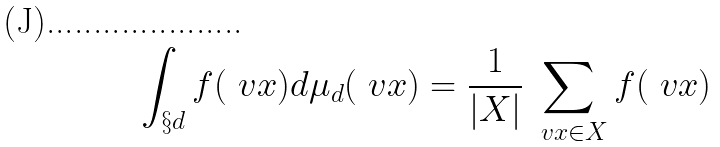<formula> <loc_0><loc_0><loc_500><loc_500>\int _ { \S d } f ( \ v x ) d \mu _ { d } ( \ v x ) = \frac { 1 } { | X | } \sum _ { \ v x \in X } f ( \ v x )</formula> 